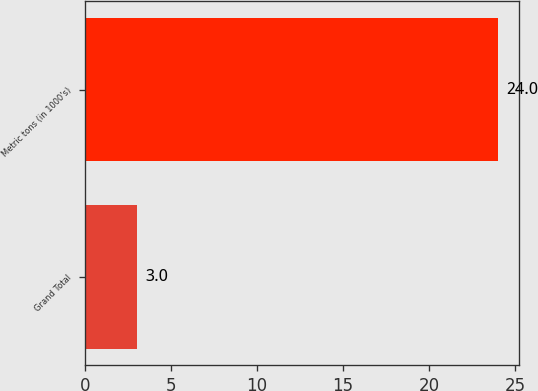<chart> <loc_0><loc_0><loc_500><loc_500><bar_chart><fcel>Grand Total<fcel>Metric tons (in 1000's)<nl><fcel>3<fcel>24<nl></chart> 